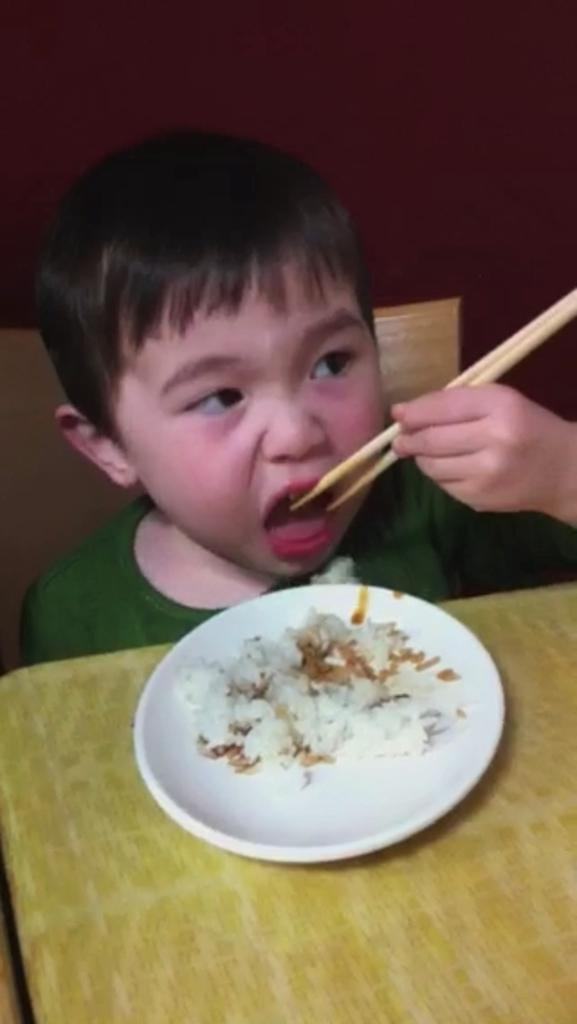Who is the main subject in the image? There is a boy in the image. What is the boy doing in the image? The boy is sitting at a dining table and eating food from a plate. What utensil is the boy using to eat the food? The boy is using chopsticks to eat the food. What type of sail is visible in the image? There is no sail present in the image; it features a boy sitting at a dining table and eating food with chopsticks. 